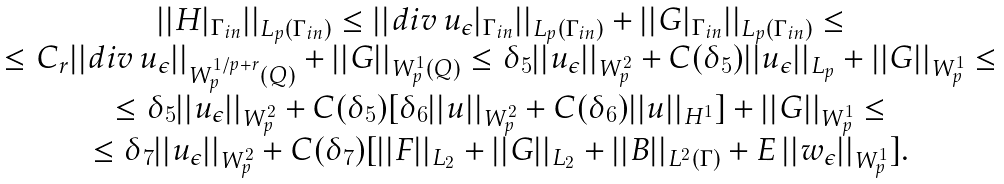<formula> <loc_0><loc_0><loc_500><loc_500>\begin{array} { c } | | H | _ { \Gamma _ { i n } } | | _ { L _ { p } ( \Gamma _ { i n } ) } \leq | | d i v \, u _ { \epsilon } | _ { \Gamma _ { i n } } | | _ { L _ { p } ( \Gamma _ { i n } ) } + | | G | _ { \Gamma _ { i n } } | | _ { L _ { p } ( \Gamma _ { i n } ) } \leq \\ \leq C _ { r } | | d i v \, u _ { \epsilon } | | _ { W ^ { 1 / p + r } _ { p } ( Q ) } + | | G | | _ { W ^ { 1 } _ { p } ( Q ) } \leq \delta _ { 5 } | | u _ { \epsilon } | | _ { W ^ { 2 } _ { p } } + C ( \delta _ { 5 } ) | | u _ { \epsilon } | | _ { L _ { p } } + | | G | | _ { W ^ { 1 } _ { p } } \leq \\ \leq \delta _ { 5 } | | u _ { \epsilon } | | _ { W ^ { 2 } _ { p } } + C ( \delta _ { 5 } ) [ \delta _ { 6 } | | u | | _ { W ^ { 2 } _ { p } } + C ( \delta _ { 6 } ) | | u | | _ { H ^ { 1 } } ] + | | G | | _ { W ^ { 1 } _ { p } } \leq \\ \leq \delta _ { 7 } | | u _ { \epsilon } | | _ { W ^ { 2 } _ { p } } + C ( \delta _ { 7 } ) [ | | F | | _ { L _ { 2 } } + | | G | | _ { L _ { 2 } } + | | B | | _ { L ^ { 2 } ( \Gamma ) } + E \, | | w _ { \epsilon } | | _ { W ^ { 1 } _ { p } } ] . \end{array}</formula> 